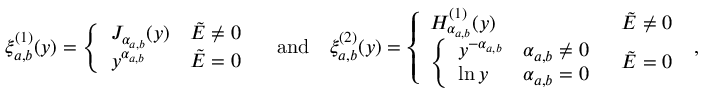Convert formula to latex. <formula><loc_0><loc_0><loc_500><loc_500>\xi _ { a , b } ^ { ( 1 ) } ( y ) = \left \{ \begin{array} { l l } { J _ { \alpha _ { a , b } } ( y ) } & { \tilde { E } \neq 0 } \\ { y ^ { \alpha _ { a , b } } } & { \tilde { E } = 0 } \end{array} \quad a n d \quad \xi _ { a , b } ^ { ( 2 ) } ( y ) = \left \{ \begin{array} { l l } { H _ { \alpha _ { a , b } } ^ { ( 1 ) } ( y ) } & { \tilde { E } \neq 0 } \\ { \left \{ \begin{array} { l l } { y ^ { - \alpha _ { a , b } } } & { \alpha _ { a , b } \neq 0 } \\ { \ln { y } } & { \alpha _ { a , b } = 0 } \end{array} } & { \tilde { E } = 0 } \end{array} \, ,</formula> 